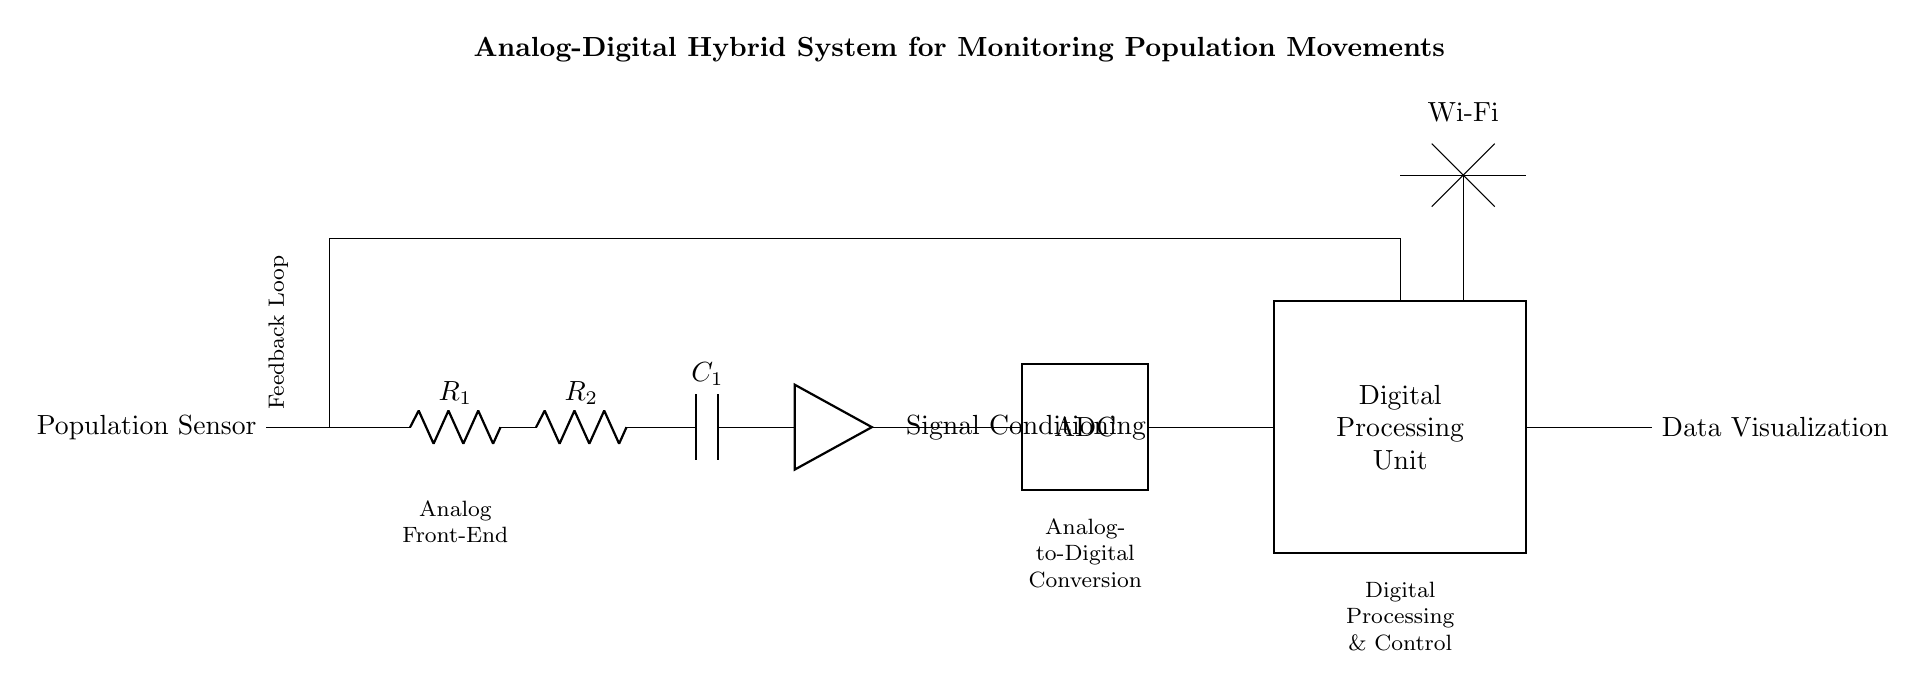What component performs signal conditioning in this circuit? The component that performs signal conditioning is indicated by the label next to the amp symbol. This suggests that it processes the signal coming from the population sensor.
Answer: Signal Conditioning What does ADC stand for in the diagram? The label "ADC" in a thick rectangle represents the component responsible for converting analog signals to digital format. ADC stands for Analog-to-Digital Converter.
Answer: Analog-to-Digital Converter How many resistors are present in the circuit? The circuit diagram shows two resistors labeled R1 and R2 connected in series. Counting these gives a total of two resistors.
Answer: 2 What unit represents the final output of the circuit? The output of the circuit is labeled as "Data Visualization," indicating that the final unit focuses on visual display.
Answer: Data Visualization What is the primary function of the Digital Processing Unit? The Digital Processing Unit processes the digital signals received from the ADC, allowing for the analysis of population movement data. This unit is marked as a section that handles the digital interpretation of the signals.
Answer: Processing What type of feedback mechanism is included in the circuit? The circuit includes a feedback loop indicated by the lines looping back to the population sensor, which suggests a feedback mechanism for adjusting the data being monitored.
Answer: Feedback Loop What technology enables connectivity in this circuit? The circuit features a Wi-Fi label, indicating that wireless communication technology is used for data transmission. This is crucial for transmitting data in real-time.
Answer: Wi-Fi 